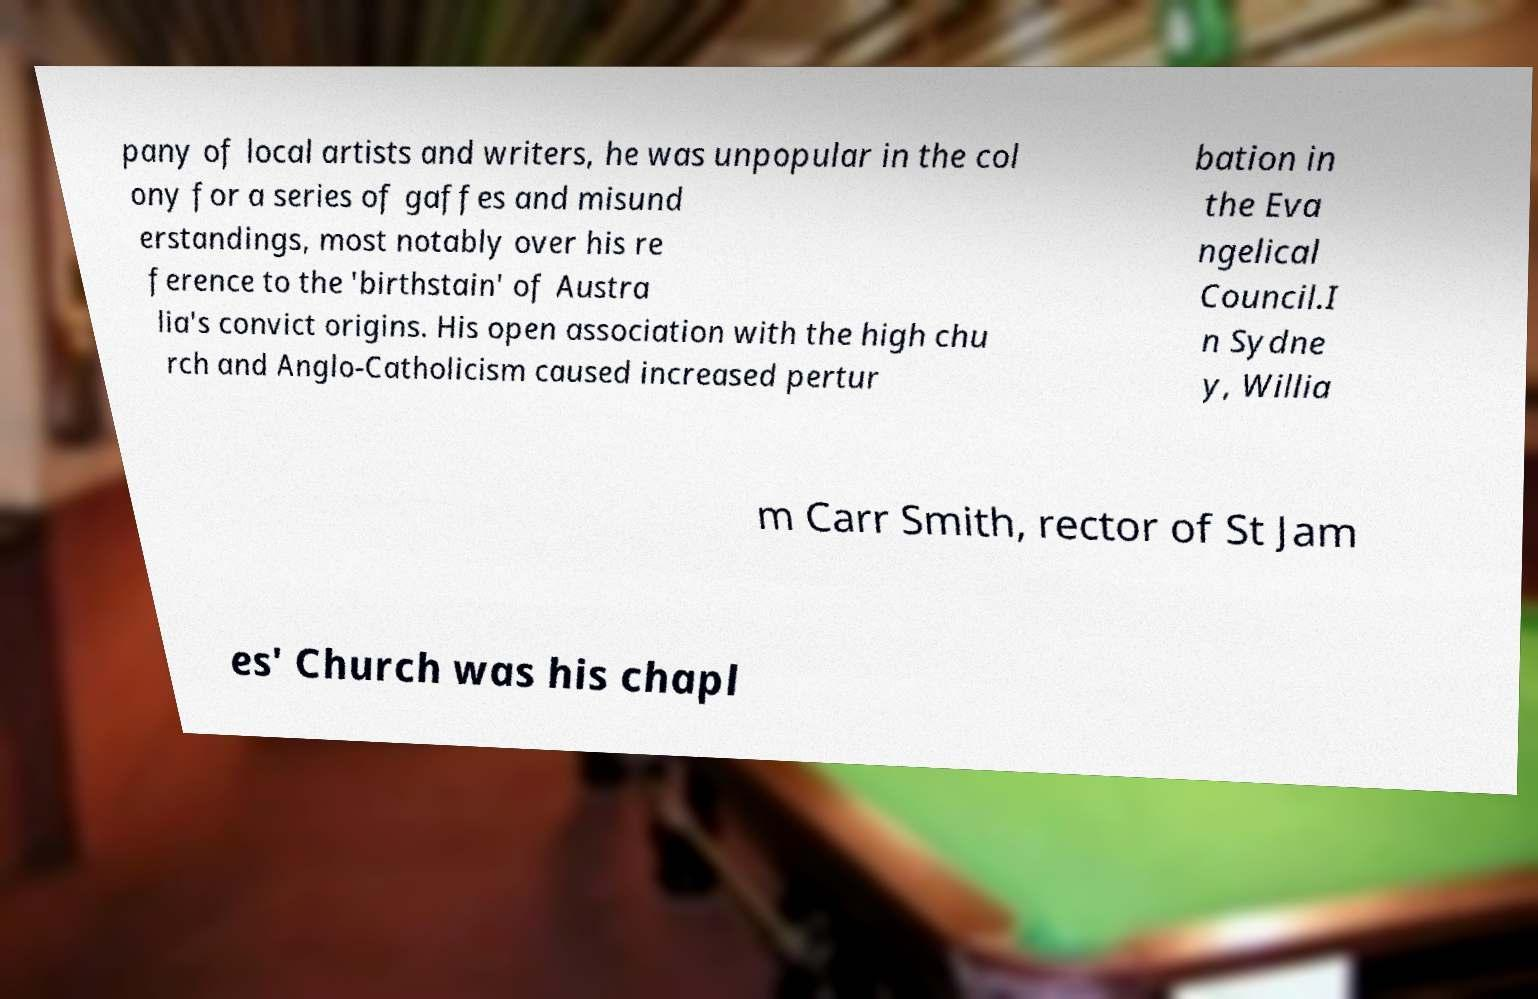For documentation purposes, I need the text within this image transcribed. Could you provide that? pany of local artists and writers, he was unpopular in the col ony for a series of gaffes and misund erstandings, most notably over his re ference to the 'birthstain' of Austra lia's convict origins. His open association with the high chu rch and Anglo-Catholicism caused increased pertur bation in the Eva ngelical Council.I n Sydne y, Willia m Carr Smith, rector of St Jam es' Church was his chapl 